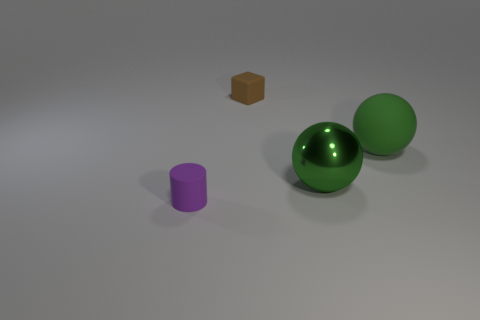There is a rubber thing that is left of the big metallic thing and right of the purple thing; what shape is it?
Give a very brief answer. Cube. There is a rubber thing to the left of the small matte cube; are there any big green matte balls in front of it?
Ensure brevity in your answer.  No. Do the small rubber object to the right of the small purple rubber cylinder and the small rubber object that is in front of the green rubber ball have the same shape?
Give a very brief answer. No. Is the purple object made of the same material as the small brown cube?
Provide a short and direct response. Yes. There is a sphere that is left of the matte thing that is right of the tiny thing to the right of the purple cylinder; what is its size?
Offer a very short reply. Large. What number of other objects are the same color as the shiny ball?
Your answer should be compact. 1. There is a purple matte object that is the same size as the block; what is its shape?
Keep it short and to the point. Cylinder. What number of tiny things are matte blocks or matte things?
Provide a short and direct response. 2. Are there any purple rubber cylinders that are in front of the small rubber object in front of the small object that is behind the tiny cylinder?
Keep it short and to the point. No. Is there a green shiny cylinder of the same size as the brown cube?
Provide a succinct answer. No. 